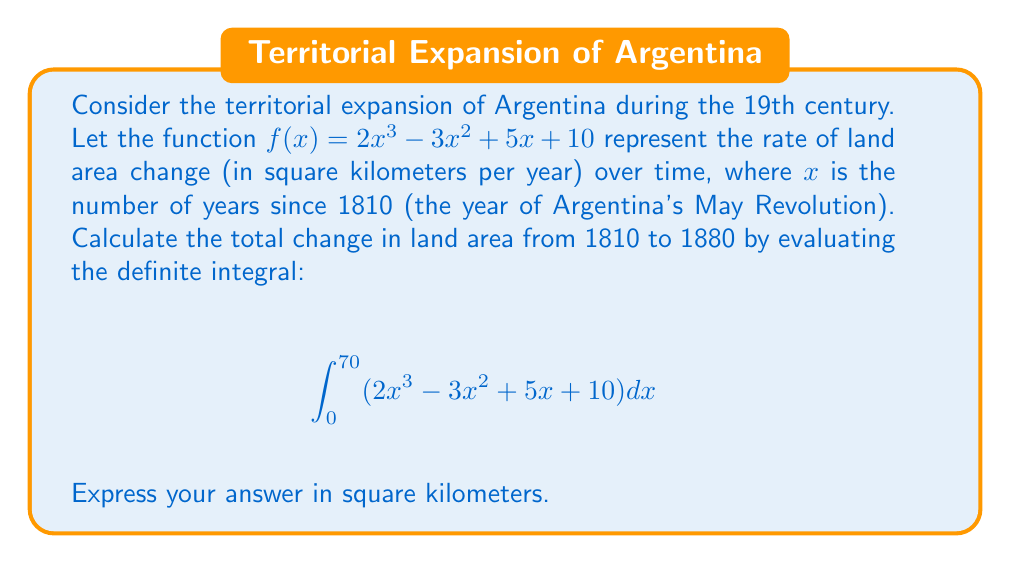What is the answer to this math problem? To solve this problem, we need to evaluate the definite integral of the given function over the specified interval. Let's break it down step by step:

1) First, we need to find the antiderivative of $f(x) = 2x^3 - 3x^2 + 5x + 10$:

   $F(x) = \frac{1}{2}x^4 - x^3 + \frac{5}{2}x^2 + 10x + C$

2) Now, we can apply the Fundamental Theorem of Calculus:

   $$\int_0^{70} (2x^3 - 3x^2 + 5x + 10) dx = F(70) - F(0)$$

3) Let's calculate $F(70)$:
   
   $F(70) = \frac{1}{2}(70^4) - (70^3) + \frac{5}{2}(70^2) + 10(70)$
   $= 6,002,500 - 343,000 + 12,250 + 700$
   $= 5,672,450$

4) Now, $F(0)$:
   
   $F(0) = \frac{1}{2}(0^4) - (0^3) + \frac{5}{2}(0^2) + 10(0) = 0$

5) Therefore, the definite integral is:

   $F(70) - F(0) = 5,672,450 - 0 = 5,672,450$

This result represents the total change in land area in square kilometers from 1810 to 1880.
Answer: $5,672,450$ square kilometers 